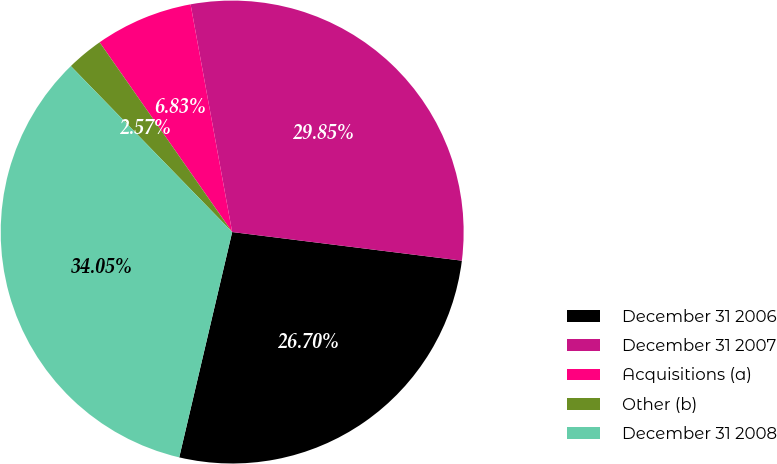Convert chart. <chart><loc_0><loc_0><loc_500><loc_500><pie_chart><fcel>December 31 2006<fcel>December 31 2007<fcel>Acquisitions (a)<fcel>Other (b)<fcel>December 31 2008<nl><fcel>26.7%<fcel>29.85%<fcel>6.83%<fcel>2.57%<fcel>34.05%<nl></chart> 